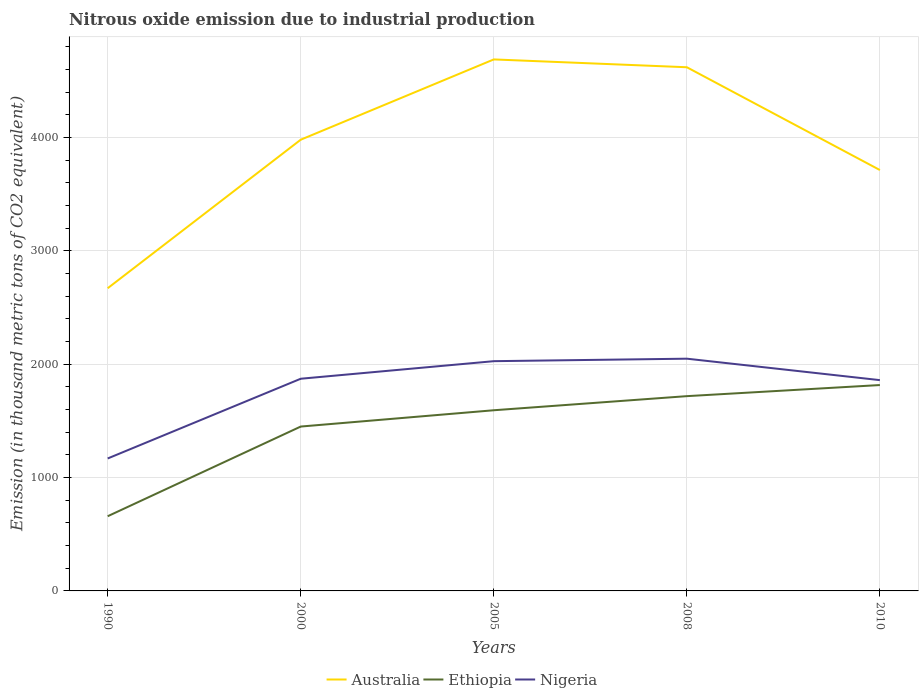How many different coloured lines are there?
Offer a terse response. 3. Does the line corresponding to Nigeria intersect with the line corresponding to Ethiopia?
Provide a succinct answer. No. Is the number of lines equal to the number of legend labels?
Provide a succinct answer. Yes. Across all years, what is the maximum amount of nitrous oxide emitted in Nigeria?
Provide a short and direct response. 1168.8. What is the total amount of nitrous oxide emitted in Australia in the graph?
Offer a very short reply. 69.1. What is the difference between the highest and the second highest amount of nitrous oxide emitted in Australia?
Your answer should be compact. 2019.1. Is the amount of nitrous oxide emitted in Australia strictly greater than the amount of nitrous oxide emitted in Ethiopia over the years?
Provide a succinct answer. No. What is the difference between two consecutive major ticks on the Y-axis?
Give a very brief answer. 1000. Does the graph contain any zero values?
Provide a succinct answer. No. Does the graph contain grids?
Your response must be concise. Yes. Where does the legend appear in the graph?
Provide a short and direct response. Bottom center. What is the title of the graph?
Keep it short and to the point. Nitrous oxide emission due to industrial production. What is the label or title of the X-axis?
Your response must be concise. Years. What is the label or title of the Y-axis?
Provide a succinct answer. Emission (in thousand metric tons of CO2 equivalent). What is the Emission (in thousand metric tons of CO2 equivalent) in Australia in 1990?
Your answer should be compact. 2671. What is the Emission (in thousand metric tons of CO2 equivalent) in Ethiopia in 1990?
Offer a very short reply. 659.1. What is the Emission (in thousand metric tons of CO2 equivalent) of Nigeria in 1990?
Your answer should be compact. 1168.8. What is the Emission (in thousand metric tons of CO2 equivalent) of Australia in 2000?
Provide a succinct answer. 3981.7. What is the Emission (in thousand metric tons of CO2 equivalent) of Ethiopia in 2000?
Make the answer very short. 1450.5. What is the Emission (in thousand metric tons of CO2 equivalent) of Nigeria in 2000?
Ensure brevity in your answer.  1872.4. What is the Emission (in thousand metric tons of CO2 equivalent) in Australia in 2005?
Make the answer very short. 4690.1. What is the Emission (in thousand metric tons of CO2 equivalent) of Ethiopia in 2005?
Provide a short and direct response. 1594.3. What is the Emission (in thousand metric tons of CO2 equivalent) in Nigeria in 2005?
Ensure brevity in your answer.  2027.3. What is the Emission (in thousand metric tons of CO2 equivalent) in Australia in 2008?
Make the answer very short. 4621. What is the Emission (in thousand metric tons of CO2 equivalent) in Ethiopia in 2008?
Your response must be concise. 1718.7. What is the Emission (in thousand metric tons of CO2 equivalent) of Nigeria in 2008?
Keep it short and to the point. 2049.3. What is the Emission (in thousand metric tons of CO2 equivalent) of Australia in 2010?
Your answer should be very brief. 3714. What is the Emission (in thousand metric tons of CO2 equivalent) of Ethiopia in 2010?
Ensure brevity in your answer.  1816.7. What is the Emission (in thousand metric tons of CO2 equivalent) of Nigeria in 2010?
Provide a short and direct response. 1860. Across all years, what is the maximum Emission (in thousand metric tons of CO2 equivalent) of Australia?
Provide a short and direct response. 4690.1. Across all years, what is the maximum Emission (in thousand metric tons of CO2 equivalent) in Ethiopia?
Your response must be concise. 1816.7. Across all years, what is the maximum Emission (in thousand metric tons of CO2 equivalent) in Nigeria?
Your response must be concise. 2049.3. Across all years, what is the minimum Emission (in thousand metric tons of CO2 equivalent) in Australia?
Keep it short and to the point. 2671. Across all years, what is the minimum Emission (in thousand metric tons of CO2 equivalent) in Ethiopia?
Offer a terse response. 659.1. Across all years, what is the minimum Emission (in thousand metric tons of CO2 equivalent) of Nigeria?
Offer a terse response. 1168.8. What is the total Emission (in thousand metric tons of CO2 equivalent) in Australia in the graph?
Make the answer very short. 1.97e+04. What is the total Emission (in thousand metric tons of CO2 equivalent) in Ethiopia in the graph?
Your response must be concise. 7239.3. What is the total Emission (in thousand metric tons of CO2 equivalent) of Nigeria in the graph?
Give a very brief answer. 8977.8. What is the difference between the Emission (in thousand metric tons of CO2 equivalent) of Australia in 1990 and that in 2000?
Ensure brevity in your answer.  -1310.7. What is the difference between the Emission (in thousand metric tons of CO2 equivalent) of Ethiopia in 1990 and that in 2000?
Give a very brief answer. -791.4. What is the difference between the Emission (in thousand metric tons of CO2 equivalent) of Nigeria in 1990 and that in 2000?
Offer a terse response. -703.6. What is the difference between the Emission (in thousand metric tons of CO2 equivalent) of Australia in 1990 and that in 2005?
Your answer should be very brief. -2019.1. What is the difference between the Emission (in thousand metric tons of CO2 equivalent) of Ethiopia in 1990 and that in 2005?
Your answer should be compact. -935.2. What is the difference between the Emission (in thousand metric tons of CO2 equivalent) in Nigeria in 1990 and that in 2005?
Your answer should be very brief. -858.5. What is the difference between the Emission (in thousand metric tons of CO2 equivalent) in Australia in 1990 and that in 2008?
Your answer should be very brief. -1950. What is the difference between the Emission (in thousand metric tons of CO2 equivalent) of Ethiopia in 1990 and that in 2008?
Make the answer very short. -1059.6. What is the difference between the Emission (in thousand metric tons of CO2 equivalent) of Nigeria in 1990 and that in 2008?
Keep it short and to the point. -880.5. What is the difference between the Emission (in thousand metric tons of CO2 equivalent) of Australia in 1990 and that in 2010?
Keep it short and to the point. -1043. What is the difference between the Emission (in thousand metric tons of CO2 equivalent) of Ethiopia in 1990 and that in 2010?
Your response must be concise. -1157.6. What is the difference between the Emission (in thousand metric tons of CO2 equivalent) of Nigeria in 1990 and that in 2010?
Make the answer very short. -691.2. What is the difference between the Emission (in thousand metric tons of CO2 equivalent) of Australia in 2000 and that in 2005?
Your answer should be very brief. -708.4. What is the difference between the Emission (in thousand metric tons of CO2 equivalent) in Ethiopia in 2000 and that in 2005?
Provide a succinct answer. -143.8. What is the difference between the Emission (in thousand metric tons of CO2 equivalent) of Nigeria in 2000 and that in 2005?
Provide a short and direct response. -154.9. What is the difference between the Emission (in thousand metric tons of CO2 equivalent) in Australia in 2000 and that in 2008?
Ensure brevity in your answer.  -639.3. What is the difference between the Emission (in thousand metric tons of CO2 equivalent) in Ethiopia in 2000 and that in 2008?
Your answer should be compact. -268.2. What is the difference between the Emission (in thousand metric tons of CO2 equivalent) of Nigeria in 2000 and that in 2008?
Provide a short and direct response. -176.9. What is the difference between the Emission (in thousand metric tons of CO2 equivalent) in Australia in 2000 and that in 2010?
Provide a short and direct response. 267.7. What is the difference between the Emission (in thousand metric tons of CO2 equivalent) of Ethiopia in 2000 and that in 2010?
Provide a short and direct response. -366.2. What is the difference between the Emission (in thousand metric tons of CO2 equivalent) in Nigeria in 2000 and that in 2010?
Your answer should be very brief. 12.4. What is the difference between the Emission (in thousand metric tons of CO2 equivalent) in Australia in 2005 and that in 2008?
Give a very brief answer. 69.1. What is the difference between the Emission (in thousand metric tons of CO2 equivalent) in Ethiopia in 2005 and that in 2008?
Your response must be concise. -124.4. What is the difference between the Emission (in thousand metric tons of CO2 equivalent) of Australia in 2005 and that in 2010?
Ensure brevity in your answer.  976.1. What is the difference between the Emission (in thousand metric tons of CO2 equivalent) of Ethiopia in 2005 and that in 2010?
Your answer should be very brief. -222.4. What is the difference between the Emission (in thousand metric tons of CO2 equivalent) in Nigeria in 2005 and that in 2010?
Your answer should be very brief. 167.3. What is the difference between the Emission (in thousand metric tons of CO2 equivalent) in Australia in 2008 and that in 2010?
Give a very brief answer. 907. What is the difference between the Emission (in thousand metric tons of CO2 equivalent) in Ethiopia in 2008 and that in 2010?
Offer a terse response. -98. What is the difference between the Emission (in thousand metric tons of CO2 equivalent) in Nigeria in 2008 and that in 2010?
Your answer should be very brief. 189.3. What is the difference between the Emission (in thousand metric tons of CO2 equivalent) of Australia in 1990 and the Emission (in thousand metric tons of CO2 equivalent) of Ethiopia in 2000?
Provide a short and direct response. 1220.5. What is the difference between the Emission (in thousand metric tons of CO2 equivalent) in Australia in 1990 and the Emission (in thousand metric tons of CO2 equivalent) in Nigeria in 2000?
Your answer should be compact. 798.6. What is the difference between the Emission (in thousand metric tons of CO2 equivalent) of Ethiopia in 1990 and the Emission (in thousand metric tons of CO2 equivalent) of Nigeria in 2000?
Offer a very short reply. -1213.3. What is the difference between the Emission (in thousand metric tons of CO2 equivalent) in Australia in 1990 and the Emission (in thousand metric tons of CO2 equivalent) in Ethiopia in 2005?
Give a very brief answer. 1076.7. What is the difference between the Emission (in thousand metric tons of CO2 equivalent) in Australia in 1990 and the Emission (in thousand metric tons of CO2 equivalent) in Nigeria in 2005?
Ensure brevity in your answer.  643.7. What is the difference between the Emission (in thousand metric tons of CO2 equivalent) of Ethiopia in 1990 and the Emission (in thousand metric tons of CO2 equivalent) of Nigeria in 2005?
Your response must be concise. -1368.2. What is the difference between the Emission (in thousand metric tons of CO2 equivalent) in Australia in 1990 and the Emission (in thousand metric tons of CO2 equivalent) in Ethiopia in 2008?
Ensure brevity in your answer.  952.3. What is the difference between the Emission (in thousand metric tons of CO2 equivalent) of Australia in 1990 and the Emission (in thousand metric tons of CO2 equivalent) of Nigeria in 2008?
Your answer should be very brief. 621.7. What is the difference between the Emission (in thousand metric tons of CO2 equivalent) in Ethiopia in 1990 and the Emission (in thousand metric tons of CO2 equivalent) in Nigeria in 2008?
Make the answer very short. -1390.2. What is the difference between the Emission (in thousand metric tons of CO2 equivalent) in Australia in 1990 and the Emission (in thousand metric tons of CO2 equivalent) in Ethiopia in 2010?
Provide a short and direct response. 854.3. What is the difference between the Emission (in thousand metric tons of CO2 equivalent) in Australia in 1990 and the Emission (in thousand metric tons of CO2 equivalent) in Nigeria in 2010?
Ensure brevity in your answer.  811. What is the difference between the Emission (in thousand metric tons of CO2 equivalent) in Ethiopia in 1990 and the Emission (in thousand metric tons of CO2 equivalent) in Nigeria in 2010?
Make the answer very short. -1200.9. What is the difference between the Emission (in thousand metric tons of CO2 equivalent) of Australia in 2000 and the Emission (in thousand metric tons of CO2 equivalent) of Ethiopia in 2005?
Keep it short and to the point. 2387.4. What is the difference between the Emission (in thousand metric tons of CO2 equivalent) of Australia in 2000 and the Emission (in thousand metric tons of CO2 equivalent) of Nigeria in 2005?
Your answer should be very brief. 1954.4. What is the difference between the Emission (in thousand metric tons of CO2 equivalent) in Ethiopia in 2000 and the Emission (in thousand metric tons of CO2 equivalent) in Nigeria in 2005?
Keep it short and to the point. -576.8. What is the difference between the Emission (in thousand metric tons of CO2 equivalent) in Australia in 2000 and the Emission (in thousand metric tons of CO2 equivalent) in Ethiopia in 2008?
Your response must be concise. 2263. What is the difference between the Emission (in thousand metric tons of CO2 equivalent) of Australia in 2000 and the Emission (in thousand metric tons of CO2 equivalent) of Nigeria in 2008?
Ensure brevity in your answer.  1932.4. What is the difference between the Emission (in thousand metric tons of CO2 equivalent) of Ethiopia in 2000 and the Emission (in thousand metric tons of CO2 equivalent) of Nigeria in 2008?
Your answer should be very brief. -598.8. What is the difference between the Emission (in thousand metric tons of CO2 equivalent) in Australia in 2000 and the Emission (in thousand metric tons of CO2 equivalent) in Ethiopia in 2010?
Provide a short and direct response. 2165. What is the difference between the Emission (in thousand metric tons of CO2 equivalent) of Australia in 2000 and the Emission (in thousand metric tons of CO2 equivalent) of Nigeria in 2010?
Give a very brief answer. 2121.7. What is the difference between the Emission (in thousand metric tons of CO2 equivalent) of Ethiopia in 2000 and the Emission (in thousand metric tons of CO2 equivalent) of Nigeria in 2010?
Your answer should be very brief. -409.5. What is the difference between the Emission (in thousand metric tons of CO2 equivalent) in Australia in 2005 and the Emission (in thousand metric tons of CO2 equivalent) in Ethiopia in 2008?
Your answer should be very brief. 2971.4. What is the difference between the Emission (in thousand metric tons of CO2 equivalent) in Australia in 2005 and the Emission (in thousand metric tons of CO2 equivalent) in Nigeria in 2008?
Make the answer very short. 2640.8. What is the difference between the Emission (in thousand metric tons of CO2 equivalent) of Ethiopia in 2005 and the Emission (in thousand metric tons of CO2 equivalent) of Nigeria in 2008?
Make the answer very short. -455. What is the difference between the Emission (in thousand metric tons of CO2 equivalent) of Australia in 2005 and the Emission (in thousand metric tons of CO2 equivalent) of Ethiopia in 2010?
Give a very brief answer. 2873.4. What is the difference between the Emission (in thousand metric tons of CO2 equivalent) in Australia in 2005 and the Emission (in thousand metric tons of CO2 equivalent) in Nigeria in 2010?
Keep it short and to the point. 2830.1. What is the difference between the Emission (in thousand metric tons of CO2 equivalent) of Ethiopia in 2005 and the Emission (in thousand metric tons of CO2 equivalent) of Nigeria in 2010?
Offer a very short reply. -265.7. What is the difference between the Emission (in thousand metric tons of CO2 equivalent) of Australia in 2008 and the Emission (in thousand metric tons of CO2 equivalent) of Ethiopia in 2010?
Offer a very short reply. 2804.3. What is the difference between the Emission (in thousand metric tons of CO2 equivalent) of Australia in 2008 and the Emission (in thousand metric tons of CO2 equivalent) of Nigeria in 2010?
Make the answer very short. 2761. What is the difference between the Emission (in thousand metric tons of CO2 equivalent) in Ethiopia in 2008 and the Emission (in thousand metric tons of CO2 equivalent) in Nigeria in 2010?
Provide a short and direct response. -141.3. What is the average Emission (in thousand metric tons of CO2 equivalent) in Australia per year?
Offer a very short reply. 3935.56. What is the average Emission (in thousand metric tons of CO2 equivalent) in Ethiopia per year?
Your answer should be compact. 1447.86. What is the average Emission (in thousand metric tons of CO2 equivalent) of Nigeria per year?
Make the answer very short. 1795.56. In the year 1990, what is the difference between the Emission (in thousand metric tons of CO2 equivalent) in Australia and Emission (in thousand metric tons of CO2 equivalent) in Ethiopia?
Ensure brevity in your answer.  2011.9. In the year 1990, what is the difference between the Emission (in thousand metric tons of CO2 equivalent) in Australia and Emission (in thousand metric tons of CO2 equivalent) in Nigeria?
Your answer should be very brief. 1502.2. In the year 1990, what is the difference between the Emission (in thousand metric tons of CO2 equivalent) of Ethiopia and Emission (in thousand metric tons of CO2 equivalent) of Nigeria?
Provide a succinct answer. -509.7. In the year 2000, what is the difference between the Emission (in thousand metric tons of CO2 equivalent) of Australia and Emission (in thousand metric tons of CO2 equivalent) of Ethiopia?
Ensure brevity in your answer.  2531.2. In the year 2000, what is the difference between the Emission (in thousand metric tons of CO2 equivalent) of Australia and Emission (in thousand metric tons of CO2 equivalent) of Nigeria?
Give a very brief answer. 2109.3. In the year 2000, what is the difference between the Emission (in thousand metric tons of CO2 equivalent) in Ethiopia and Emission (in thousand metric tons of CO2 equivalent) in Nigeria?
Your answer should be compact. -421.9. In the year 2005, what is the difference between the Emission (in thousand metric tons of CO2 equivalent) of Australia and Emission (in thousand metric tons of CO2 equivalent) of Ethiopia?
Give a very brief answer. 3095.8. In the year 2005, what is the difference between the Emission (in thousand metric tons of CO2 equivalent) in Australia and Emission (in thousand metric tons of CO2 equivalent) in Nigeria?
Offer a terse response. 2662.8. In the year 2005, what is the difference between the Emission (in thousand metric tons of CO2 equivalent) in Ethiopia and Emission (in thousand metric tons of CO2 equivalent) in Nigeria?
Your response must be concise. -433. In the year 2008, what is the difference between the Emission (in thousand metric tons of CO2 equivalent) in Australia and Emission (in thousand metric tons of CO2 equivalent) in Ethiopia?
Your response must be concise. 2902.3. In the year 2008, what is the difference between the Emission (in thousand metric tons of CO2 equivalent) in Australia and Emission (in thousand metric tons of CO2 equivalent) in Nigeria?
Your response must be concise. 2571.7. In the year 2008, what is the difference between the Emission (in thousand metric tons of CO2 equivalent) of Ethiopia and Emission (in thousand metric tons of CO2 equivalent) of Nigeria?
Offer a very short reply. -330.6. In the year 2010, what is the difference between the Emission (in thousand metric tons of CO2 equivalent) in Australia and Emission (in thousand metric tons of CO2 equivalent) in Ethiopia?
Ensure brevity in your answer.  1897.3. In the year 2010, what is the difference between the Emission (in thousand metric tons of CO2 equivalent) of Australia and Emission (in thousand metric tons of CO2 equivalent) of Nigeria?
Ensure brevity in your answer.  1854. In the year 2010, what is the difference between the Emission (in thousand metric tons of CO2 equivalent) in Ethiopia and Emission (in thousand metric tons of CO2 equivalent) in Nigeria?
Ensure brevity in your answer.  -43.3. What is the ratio of the Emission (in thousand metric tons of CO2 equivalent) in Australia in 1990 to that in 2000?
Ensure brevity in your answer.  0.67. What is the ratio of the Emission (in thousand metric tons of CO2 equivalent) of Ethiopia in 1990 to that in 2000?
Your response must be concise. 0.45. What is the ratio of the Emission (in thousand metric tons of CO2 equivalent) of Nigeria in 1990 to that in 2000?
Provide a succinct answer. 0.62. What is the ratio of the Emission (in thousand metric tons of CO2 equivalent) in Australia in 1990 to that in 2005?
Ensure brevity in your answer.  0.57. What is the ratio of the Emission (in thousand metric tons of CO2 equivalent) in Ethiopia in 1990 to that in 2005?
Keep it short and to the point. 0.41. What is the ratio of the Emission (in thousand metric tons of CO2 equivalent) in Nigeria in 1990 to that in 2005?
Your response must be concise. 0.58. What is the ratio of the Emission (in thousand metric tons of CO2 equivalent) of Australia in 1990 to that in 2008?
Keep it short and to the point. 0.58. What is the ratio of the Emission (in thousand metric tons of CO2 equivalent) of Ethiopia in 1990 to that in 2008?
Your response must be concise. 0.38. What is the ratio of the Emission (in thousand metric tons of CO2 equivalent) of Nigeria in 1990 to that in 2008?
Offer a very short reply. 0.57. What is the ratio of the Emission (in thousand metric tons of CO2 equivalent) of Australia in 1990 to that in 2010?
Make the answer very short. 0.72. What is the ratio of the Emission (in thousand metric tons of CO2 equivalent) in Ethiopia in 1990 to that in 2010?
Keep it short and to the point. 0.36. What is the ratio of the Emission (in thousand metric tons of CO2 equivalent) of Nigeria in 1990 to that in 2010?
Offer a terse response. 0.63. What is the ratio of the Emission (in thousand metric tons of CO2 equivalent) of Australia in 2000 to that in 2005?
Offer a terse response. 0.85. What is the ratio of the Emission (in thousand metric tons of CO2 equivalent) in Ethiopia in 2000 to that in 2005?
Keep it short and to the point. 0.91. What is the ratio of the Emission (in thousand metric tons of CO2 equivalent) in Nigeria in 2000 to that in 2005?
Offer a terse response. 0.92. What is the ratio of the Emission (in thousand metric tons of CO2 equivalent) of Australia in 2000 to that in 2008?
Offer a very short reply. 0.86. What is the ratio of the Emission (in thousand metric tons of CO2 equivalent) in Ethiopia in 2000 to that in 2008?
Make the answer very short. 0.84. What is the ratio of the Emission (in thousand metric tons of CO2 equivalent) in Nigeria in 2000 to that in 2008?
Your answer should be very brief. 0.91. What is the ratio of the Emission (in thousand metric tons of CO2 equivalent) in Australia in 2000 to that in 2010?
Make the answer very short. 1.07. What is the ratio of the Emission (in thousand metric tons of CO2 equivalent) in Ethiopia in 2000 to that in 2010?
Your answer should be very brief. 0.8. What is the ratio of the Emission (in thousand metric tons of CO2 equivalent) in Nigeria in 2000 to that in 2010?
Your answer should be very brief. 1.01. What is the ratio of the Emission (in thousand metric tons of CO2 equivalent) in Ethiopia in 2005 to that in 2008?
Offer a terse response. 0.93. What is the ratio of the Emission (in thousand metric tons of CO2 equivalent) of Nigeria in 2005 to that in 2008?
Your answer should be compact. 0.99. What is the ratio of the Emission (in thousand metric tons of CO2 equivalent) in Australia in 2005 to that in 2010?
Make the answer very short. 1.26. What is the ratio of the Emission (in thousand metric tons of CO2 equivalent) of Ethiopia in 2005 to that in 2010?
Offer a terse response. 0.88. What is the ratio of the Emission (in thousand metric tons of CO2 equivalent) in Nigeria in 2005 to that in 2010?
Keep it short and to the point. 1.09. What is the ratio of the Emission (in thousand metric tons of CO2 equivalent) of Australia in 2008 to that in 2010?
Provide a succinct answer. 1.24. What is the ratio of the Emission (in thousand metric tons of CO2 equivalent) of Ethiopia in 2008 to that in 2010?
Offer a terse response. 0.95. What is the ratio of the Emission (in thousand metric tons of CO2 equivalent) of Nigeria in 2008 to that in 2010?
Keep it short and to the point. 1.1. What is the difference between the highest and the second highest Emission (in thousand metric tons of CO2 equivalent) in Australia?
Your answer should be compact. 69.1. What is the difference between the highest and the second highest Emission (in thousand metric tons of CO2 equivalent) in Nigeria?
Keep it short and to the point. 22. What is the difference between the highest and the lowest Emission (in thousand metric tons of CO2 equivalent) of Australia?
Keep it short and to the point. 2019.1. What is the difference between the highest and the lowest Emission (in thousand metric tons of CO2 equivalent) in Ethiopia?
Provide a succinct answer. 1157.6. What is the difference between the highest and the lowest Emission (in thousand metric tons of CO2 equivalent) in Nigeria?
Your answer should be compact. 880.5. 